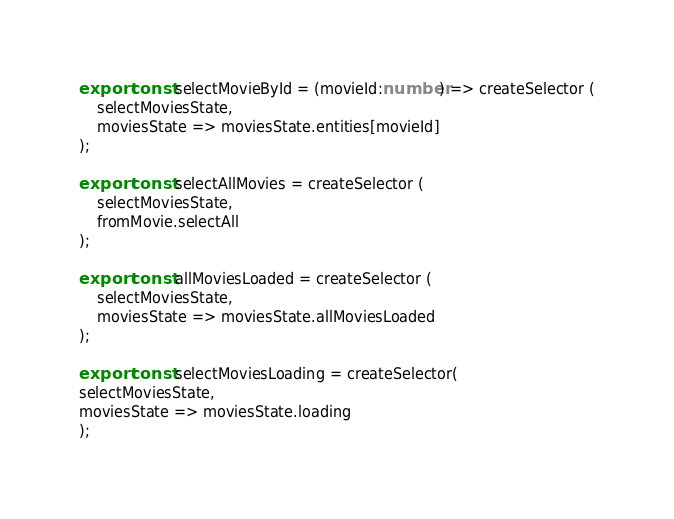<code> <loc_0><loc_0><loc_500><loc_500><_TypeScript_>export const selectMovieById = (movieId:number) => createSelector (
    selectMoviesState,
    moviesState => moviesState.entities[movieId]
);

export const selectAllMovies = createSelector (
    selectMoviesState,
    fromMovie.selectAll
);

export const allMoviesLoaded = createSelector (
    selectMoviesState,
    moviesState => moviesState.allMoviesLoaded
);

export const selectMoviesLoading = createSelector(
selectMoviesState,
moviesState => moviesState.loading
);


</code> 